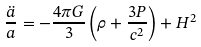Convert formula to latex. <formula><loc_0><loc_0><loc_500><loc_500>\frac { \ddot { a } } { a } = - \frac { 4 \pi G } { 3 } \left ( \rho + \frac { 3 P } { c ^ { 2 } } \right ) + H ^ { 2 }</formula> 